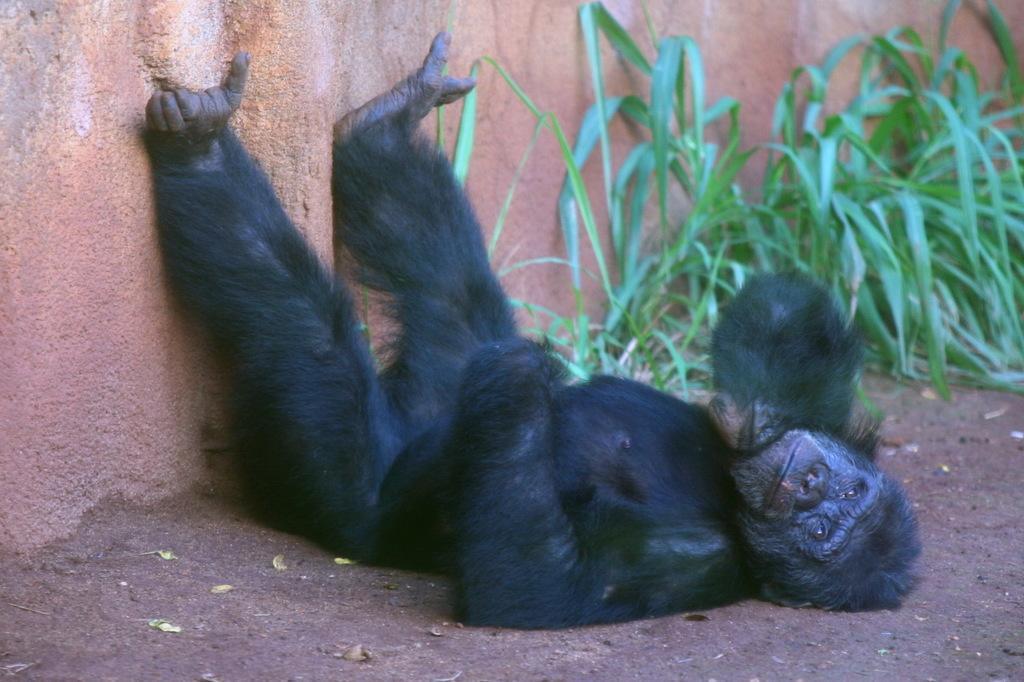Could you give a brief overview of what you see in this image? There is a gorilla lying on the ground. Near to that there is a wall. Also there are plants. 